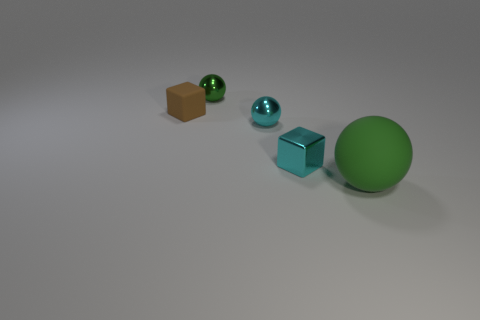There is a cyan sphere that is to the right of the brown block; what number of cyan things are to the right of it?
Provide a short and direct response. 1. There is a sphere that is behind the big green rubber ball and in front of the small rubber block; what size is it?
Ensure brevity in your answer.  Small. Are there any other cyan metal blocks of the same size as the metal block?
Provide a short and direct response. No. Are there more small green objects that are in front of the small shiny block than matte blocks behind the tiny brown rubber thing?
Make the answer very short. No. Are the brown object and the small block that is in front of the tiny matte thing made of the same material?
Offer a very short reply. No. There is a matte object that is on the right side of the small green shiny thing on the right side of the brown matte block; what number of brown blocks are left of it?
Your response must be concise. 1. There is a tiny brown matte object; is its shape the same as the cyan object right of the small cyan sphere?
Keep it short and to the point. Yes. What color is the thing that is behind the big green rubber thing and in front of the tiny cyan shiny ball?
Provide a short and direct response. Cyan. What is the small block on the left side of the tiny cyan shiny object that is in front of the cyan object that is to the left of the tiny cyan shiny block made of?
Provide a short and direct response. Rubber. What is the material of the big thing?
Offer a terse response. Rubber. 